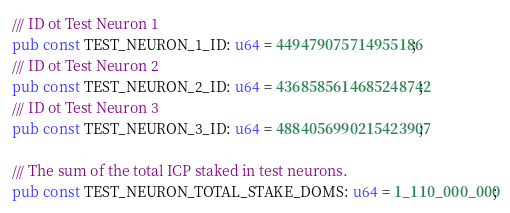Convert code to text. <code><loc_0><loc_0><loc_500><loc_500><_Rust_>
/// ID ot Test Neuron 1
pub const TEST_NEURON_1_ID: u64 = 449479075714955186;
/// ID ot Test Neuron 2
pub const TEST_NEURON_2_ID: u64 = 4368585614685248742;
/// ID ot Test Neuron 3
pub const TEST_NEURON_3_ID: u64 = 4884056990215423907;

/// The sum of the total ICP staked in test neurons.
pub const TEST_NEURON_TOTAL_STAKE_DOMS: u64 = 1_110_000_000;
</code> 